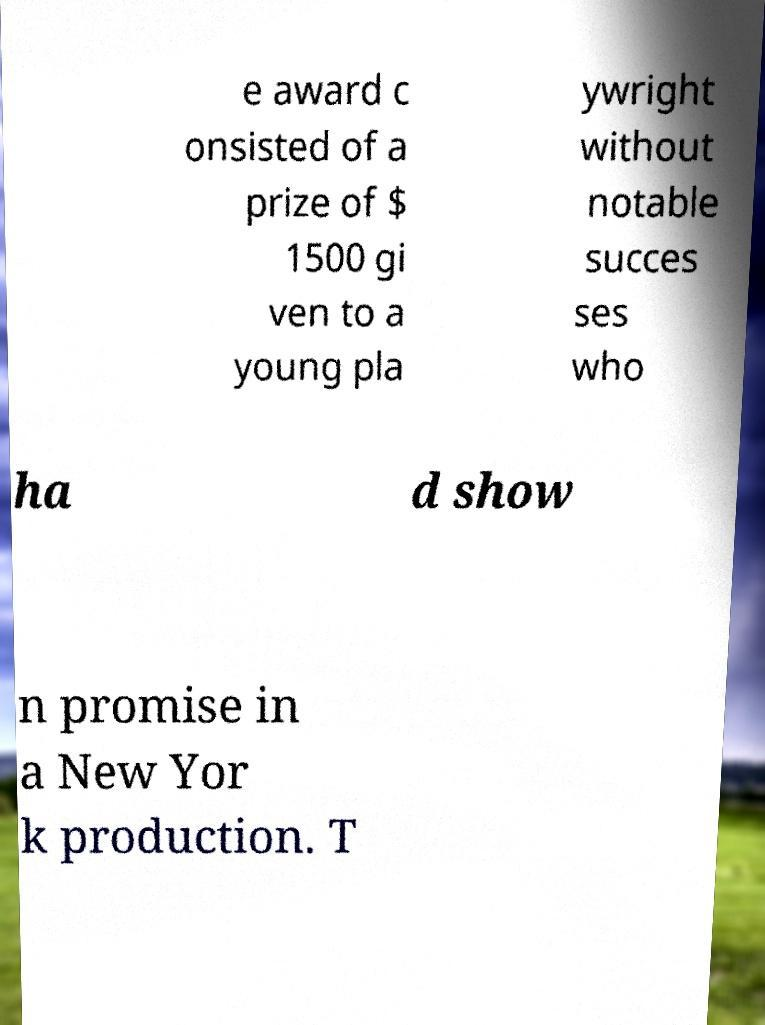Could you assist in decoding the text presented in this image and type it out clearly? e award c onsisted of a prize of $ 1500 gi ven to a young pla ywright without notable succes ses who ha d show n promise in a New Yor k production. T 